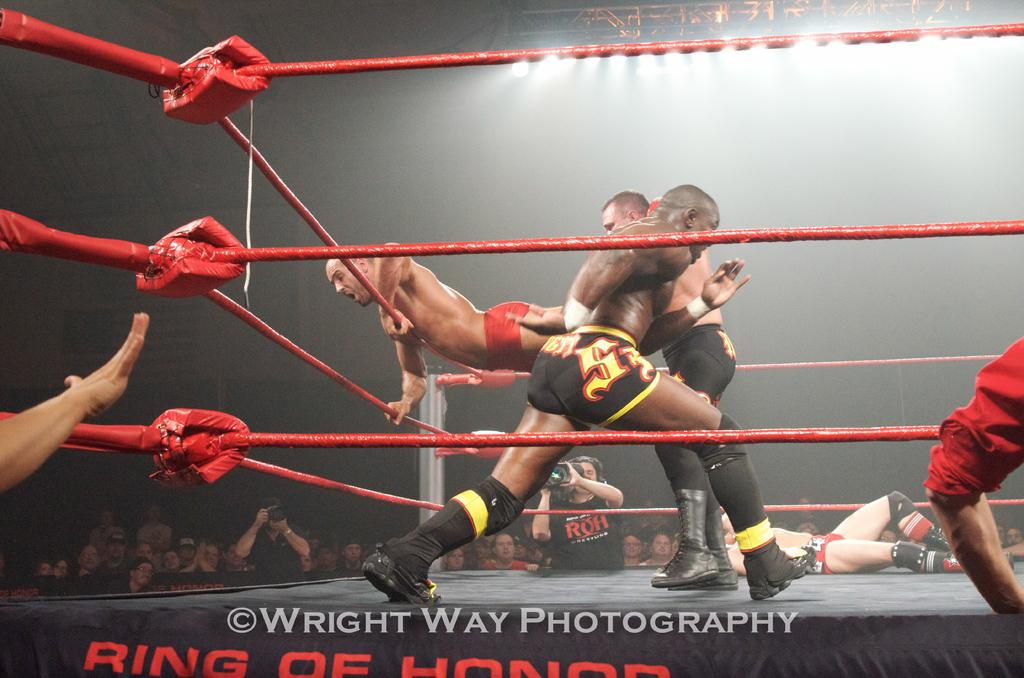Provide a one-sentence caption for the provided image. A photograph of four wrestlers in a ring by Wright Way Photography. 